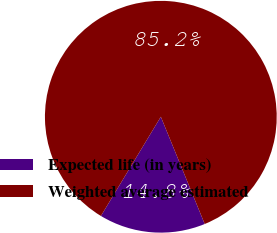Convert chart. <chart><loc_0><loc_0><loc_500><loc_500><pie_chart><fcel>Expected life (in years)<fcel>Weighted average estimated<nl><fcel>14.83%<fcel>85.17%<nl></chart> 